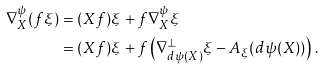<formula> <loc_0><loc_0><loc_500><loc_500>\nabla ^ { \psi } _ { X } ( f \xi ) & = ( X f ) \xi + f \nabla ^ { \psi } _ { X } \xi \\ & = ( X f ) \xi + f \left ( \nabla ^ { \perp } _ { d \psi ( X ) } \xi - A _ { \xi } ( d \psi ( X ) ) \right ) .</formula> 